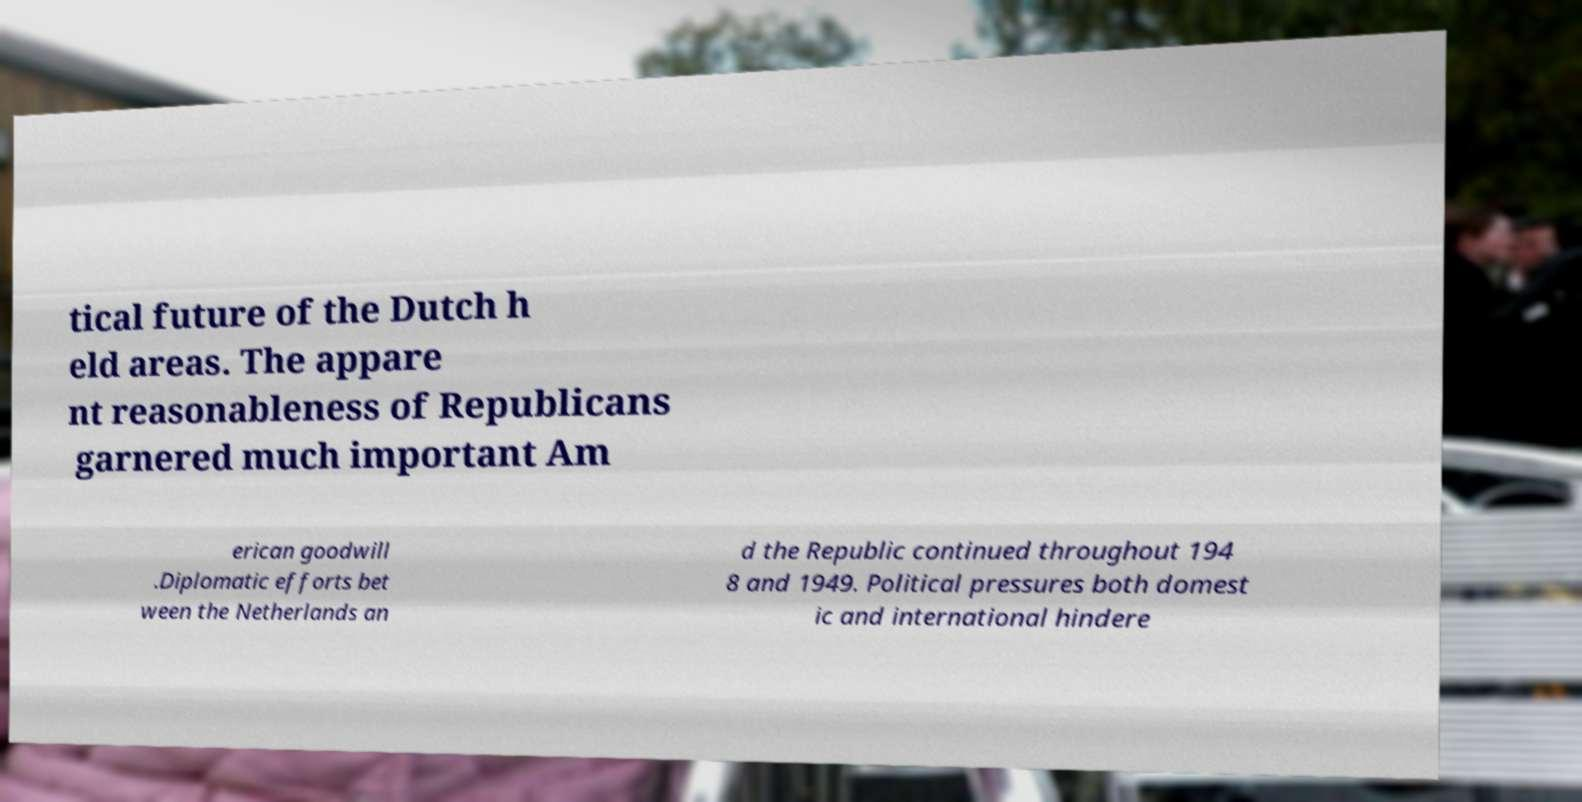Could you extract and type out the text from this image? tical future of the Dutch h eld areas. The appare nt reasonableness of Republicans garnered much important Am erican goodwill .Diplomatic efforts bet ween the Netherlands an d the Republic continued throughout 194 8 and 1949. Political pressures both domest ic and international hindere 